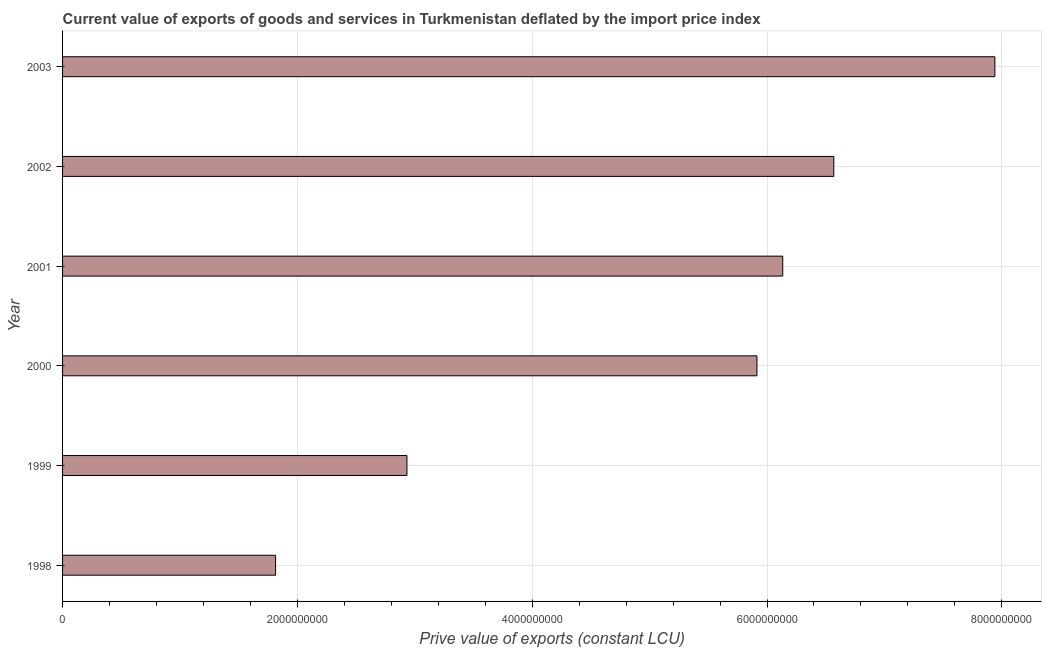What is the title of the graph?
Ensure brevity in your answer.  Current value of exports of goods and services in Turkmenistan deflated by the import price index. What is the label or title of the X-axis?
Make the answer very short. Prive value of exports (constant LCU). What is the label or title of the Y-axis?
Make the answer very short. Year. What is the price value of exports in 1999?
Give a very brief answer. 2.93e+09. Across all years, what is the maximum price value of exports?
Make the answer very short. 7.94e+09. Across all years, what is the minimum price value of exports?
Your answer should be very brief. 1.81e+09. What is the sum of the price value of exports?
Your response must be concise. 3.13e+1. What is the difference between the price value of exports in 2001 and 2002?
Offer a terse response. -4.35e+08. What is the average price value of exports per year?
Your answer should be compact. 5.22e+09. What is the median price value of exports?
Ensure brevity in your answer.  6.02e+09. Do a majority of the years between 2002 and 2000 (inclusive) have price value of exports greater than 2800000000 LCU?
Provide a short and direct response. Yes. What is the ratio of the price value of exports in 1999 to that in 2002?
Your response must be concise. 0.45. What is the difference between the highest and the second highest price value of exports?
Ensure brevity in your answer.  1.37e+09. Is the sum of the price value of exports in 2002 and 2003 greater than the maximum price value of exports across all years?
Your answer should be very brief. Yes. What is the difference between the highest and the lowest price value of exports?
Ensure brevity in your answer.  6.13e+09. How many bars are there?
Your answer should be very brief. 6. What is the Prive value of exports (constant LCU) in 1998?
Provide a succinct answer. 1.81e+09. What is the Prive value of exports (constant LCU) in 1999?
Your answer should be very brief. 2.93e+09. What is the Prive value of exports (constant LCU) in 2000?
Provide a short and direct response. 5.91e+09. What is the Prive value of exports (constant LCU) of 2001?
Make the answer very short. 6.13e+09. What is the Prive value of exports (constant LCU) in 2002?
Provide a succinct answer. 6.57e+09. What is the Prive value of exports (constant LCU) of 2003?
Give a very brief answer. 7.94e+09. What is the difference between the Prive value of exports (constant LCU) in 1998 and 1999?
Keep it short and to the point. -1.12e+09. What is the difference between the Prive value of exports (constant LCU) in 1998 and 2000?
Provide a succinct answer. -4.10e+09. What is the difference between the Prive value of exports (constant LCU) in 1998 and 2001?
Provide a short and direct response. -4.32e+09. What is the difference between the Prive value of exports (constant LCU) in 1998 and 2002?
Your response must be concise. -4.75e+09. What is the difference between the Prive value of exports (constant LCU) in 1998 and 2003?
Provide a short and direct response. -6.13e+09. What is the difference between the Prive value of exports (constant LCU) in 1999 and 2000?
Your answer should be very brief. -2.98e+09. What is the difference between the Prive value of exports (constant LCU) in 1999 and 2001?
Offer a very short reply. -3.20e+09. What is the difference between the Prive value of exports (constant LCU) in 1999 and 2002?
Make the answer very short. -3.64e+09. What is the difference between the Prive value of exports (constant LCU) in 1999 and 2003?
Your answer should be very brief. -5.01e+09. What is the difference between the Prive value of exports (constant LCU) in 2000 and 2001?
Ensure brevity in your answer.  -2.20e+08. What is the difference between the Prive value of exports (constant LCU) in 2000 and 2002?
Provide a short and direct response. -6.55e+08. What is the difference between the Prive value of exports (constant LCU) in 2000 and 2003?
Ensure brevity in your answer.  -2.03e+09. What is the difference between the Prive value of exports (constant LCU) in 2001 and 2002?
Ensure brevity in your answer.  -4.35e+08. What is the difference between the Prive value of exports (constant LCU) in 2001 and 2003?
Your answer should be compact. -1.81e+09. What is the difference between the Prive value of exports (constant LCU) in 2002 and 2003?
Provide a succinct answer. -1.37e+09. What is the ratio of the Prive value of exports (constant LCU) in 1998 to that in 1999?
Your answer should be compact. 0.62. What is the ratio of the Prive value of exports (constant LCU) in 1998 to that in 2000?
Your answer should be compact. 0.31. What is the ratio of the Prive value of exports (constant LCU) in 1998 to that in 2001?
Provide a short and direct response. 0.3. What is the ratio of the Prive value of exports (constant LCU) in 1998 to that in 2002?
Offer a very short reply. 0.28. What is the ratio of the Prive value of exports (constant LCU) in 1998 to that in 2003?
Your answer should be very brief. 0.23. What is the ratio of the Prive value of exports (constant LCU) in 1999 to that in 2000?
Provide a succinct answer. 0.5. What is the ratio of the Prive value of exports (constant LCU) in 1999 to that in 2001?
Give a very brief answer. 0.48. What is the ratio of the Prive value of exports (constant LCU) in 1999 to that in 2002?
Ensure brevity in your answer.  0.45. What is the ratio of the Prive value of exports (constant LCU) in 1999 to that in 2003?
Offer a very short reply. 0.37. What is the ratio of the Prive value of exports (constant LCU) in 2000 to that in 2003?
Keep it short and to the point. 0.74. What is the ratio of the Prive value of exports (constant LCU) in 2001 to that in 2002?
Your response must be concise. 0.93. What is the ratio of the Prive value of exports (constant LCU) in 2001 to that in 2003?
Offer a very short reply. 0.77. What is the ratio of the Prive value of exports (constant LCU) in 2002 to that in 2003?
Provide a short and direct response. 0.83. 